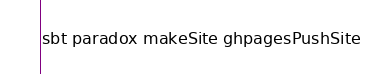<code> <loc_0><loc_0><loc_500><loc_500><_Bash_>sbt paradox makeSite ghpagesPushSite
</code> 